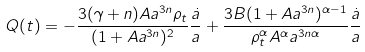Convert formula to latex. <formula><loc_0><loc_0><loc_500><loc_500>Q ( t ) = - \frac { 3 ( \gamma + n ) A a ^ { 3 n } \rho _ { t } } { ( 1 + A a ^ { 3 n } ) ^ { 2 } } \frac { \dot { a } } { a } + \frac { 3 B ( 1 + A a ^ { 3 n } ) ^ { \alpha - 1 } } { \rho _ { t } ^ { \alpha } A ^ { \alpha } a ^ { 3 n \alpha } } \frac { \dot { a } } { a }</formula> 